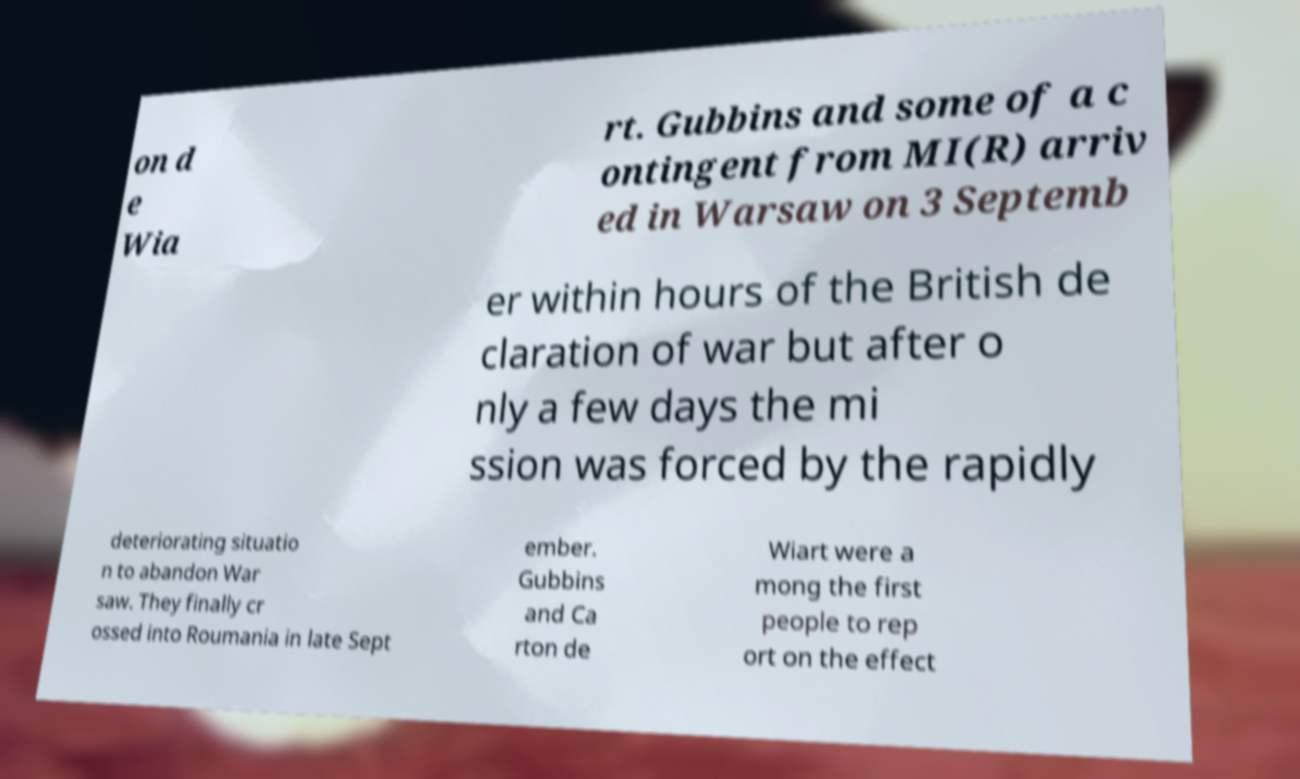Could you assist in decoding the text presented in this image and type it out clearly? on d e Wia rt. Gubbins and some of a c ontingent from MI(R) arriv ed in Warsaw on 3 Septemb er within hours of the British de claration of war but after o nly a few days the mi ssion was forced by the rapidly deteriorating situatio n to abandon War saw. They finally cr ossed into Roumania in late Sept ember. Gubbins and Ca rton de Wiart were a mong the first people to rep ort on the effect 